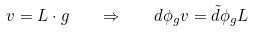Convert formula to latex. <formula><loc_0><loc_0><loc_500><loc_500>v = L \cdot g \quad \Rightarrow \quad d \phi _ { g } v = \tilde { d } \phi _ { g } L</formula> 